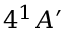<formula> <loc_0><loc_0><loc_500><loc_500>4 ^ { 1 } A ^ { \prime }</formula> 